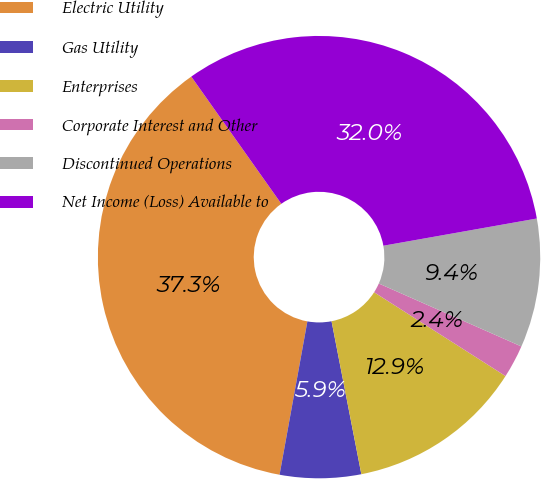<chart> <loc_0><loc_0><loc_500><loc_500><pie_chart><fcel>Electric Utility<fcel>Gas Utility<fcel>Enterprises<fcel>Corporate Interest and Other<fcel>Discontinued Operations<fcel>Net Income (Loss) Available to<nl><fcel>37.34%<fcel>5.92%<fcel>12.9%<fcel>2.42%<fcel>9.41%<fcel>32.01%<nl></chart> 